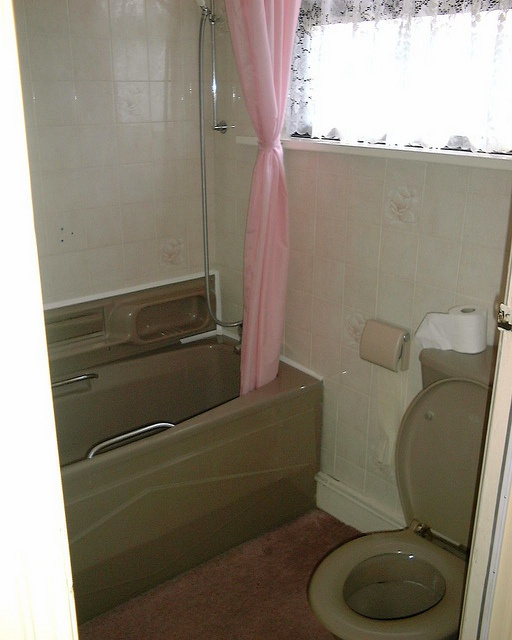Describe the objects in this image and their specific colors. I can see a toilet in ivory, darkgreen, black, and gray tones in this image. 